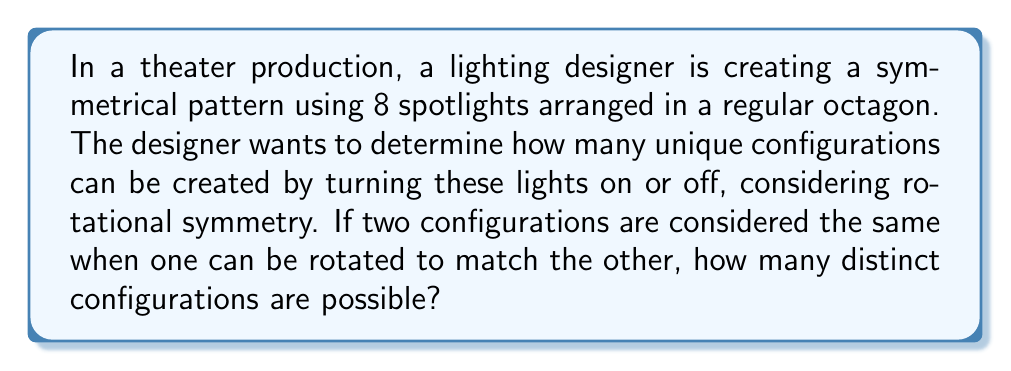What is the answer to this math problem? To solve this problem, we need to consider the symmetry group of the octagon and use Burnside's lemma. Let's approach this step-by-step:

1) The symmetry group of an octagon is the dihedral group $D_8$, which has 16 elements: 8 rotations (including identity) and 8 reflections.

2) For this problem, we only consider rotational symmetry, so we're working with the cyclic group $C_8$ (a subgroup of $D_8$).

3) Each spotlight can be in one of two states (on or off), so without considering symmetry, there would be $2^8 = 256$ total configurations.

4) Burnside's lemma states that the number of orbits (distinct configurations) is:

   $$|X/G| = \frac{1}{|G|} \sum_{g \in G} |X^g|$$

   where $|X/G|$ is the number of orbits, $|G|$ is the order of the group, and $|X^g|$ is the number of elements fixed by each group element $g$.

5) For $C_8$, we have:
   - Identity rotation (0°): fixes all $2^8 = 256$ configurations
   - 45° rotation: fixes $2^1 = 2$ configurations (all lights on or all off)
   - 90° rotation: fixes $2^2 = 4$ configurations
   - 135° rotation: fixes $2^1 = 2$ configurations
   - 180° rotation: fixes $2^4 = 16$ configurations
   - 225° rotation: fixes $2^1 = 2$ configurations
   - 270° rotation: fixes $2^2 = 4$ configurations
   - 315° rotation: fixes $2^1 = 2$ configurations

6) Applying Burnside's lemma:

   $$|X/G| = \frac{1}{8}(256 + 2 + 4 + 2 + 16 + 2 + 4 + 2) = \frac{288}{8} = 36$$

Therefore, there are 36 distinct configurations considering rotational symmetry.
Answer: 36 distinct configurations 